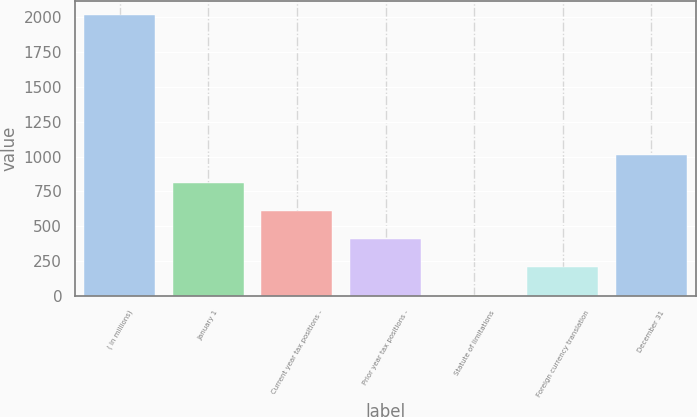Convert chart. <chart><loc_0><loc_0><loc_500><loc_500><bar_chart><fcel>( in millions)<fcel>January 1<fcel>Current year tax positions -<fcel>Prior year tax positions -<fcel>Statute of limitations<fcel>Foreign currency translation<fcel>December 31<nl><fcel>2017<fcel>811.6<fcel>610.7<fcel>409.8<fcel>8<fcel>208.9<fcel>1012.5<nl></chart> 